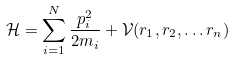<formula> <loc_0><loc_0><loc_500><loc_500>\mathcal { H } = \sum _ { i = 1 } ^ { N } \frac { p _ { i } ^ { 2 } } { 2 m _ { i } } + \mathcal { V } ( r _ { 1 } , r _ { 2 } , \dots r _ { n } )</formula> 